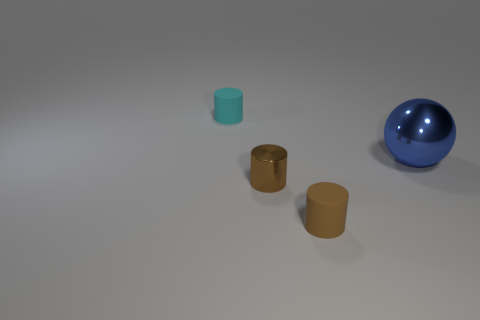Add 1 cyan cylinders. How many objects exist? 5 Subtract all cylinders. How many objects are left? 1 Subtract all tiny yellow shiny cylinders. Subtract all big blue metal objects. How many objects are left? 3 Add 2 tiny cyan matte things. How many tiny cyan matte things are left? 3 Add 3 small rubber cylinders. How many small rubber cylinders exist? 5 Subtract 0 red cubes. How many objects are left? 4 